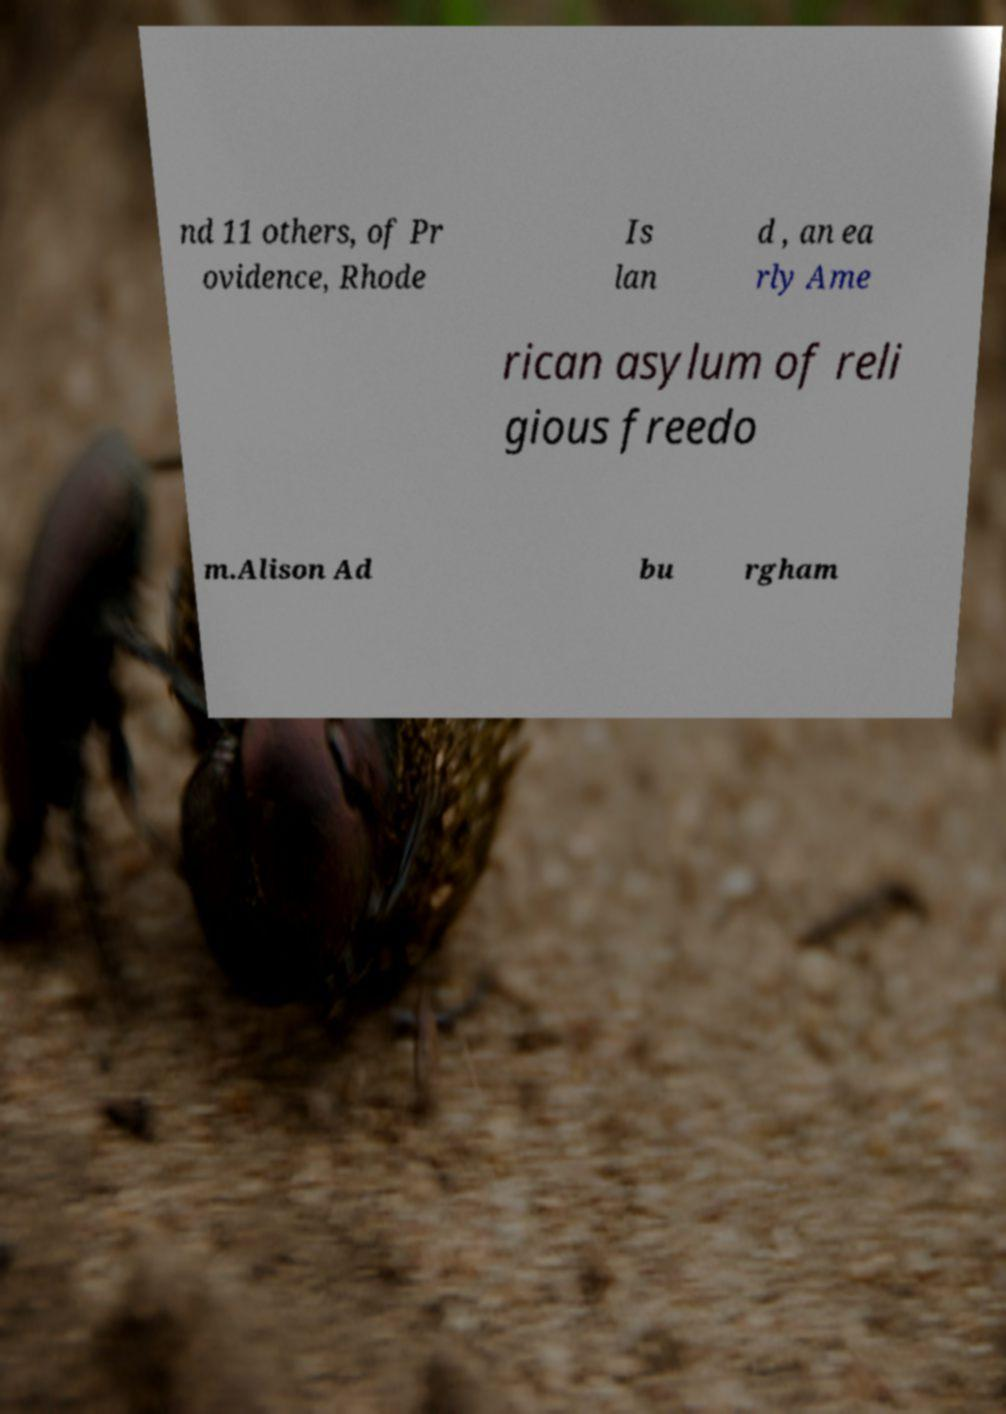Can you read and provide the text displayed in the image?This photo seems to have some interesting text. Can you extract and type it out for me? nd 11 others, of Pr ovidence, Rhode Is lan d , an ea rly Ame rican asylum of reli gious freedo m.Alison Ad bu rgham 